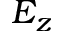Convert formula to latex. <formula><loc_0><loc_0><loc_500><loc_500>E _ { z }</formula> 